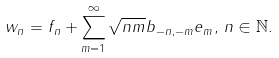<formula> <loc_0><loc_0><loc_500><loc_500>w _ { n } = f _ { n } + \sum _ { m = 1 } ^ { \infty } \sqrt { n m } b _ { - n , - m } e _ { m } , \, n \in \mathbb { N } .</formula> 